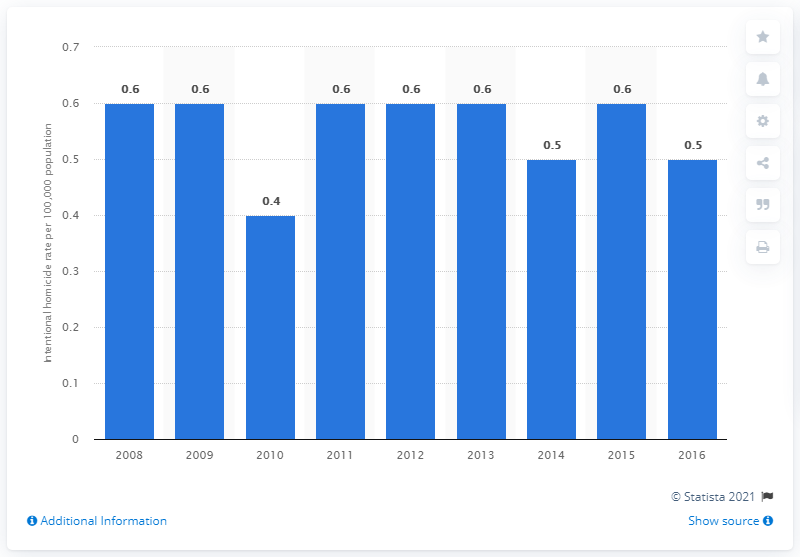Indicate a few pertinent items in this graphic. The homicide rate remains constant for 6 years. The average of 2012 and 2013 is 0.6. 